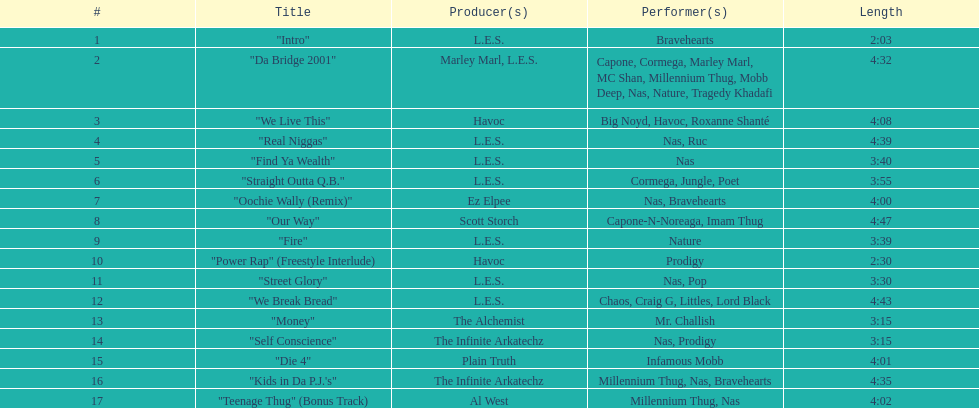Who made the last track on the album? Al West. 